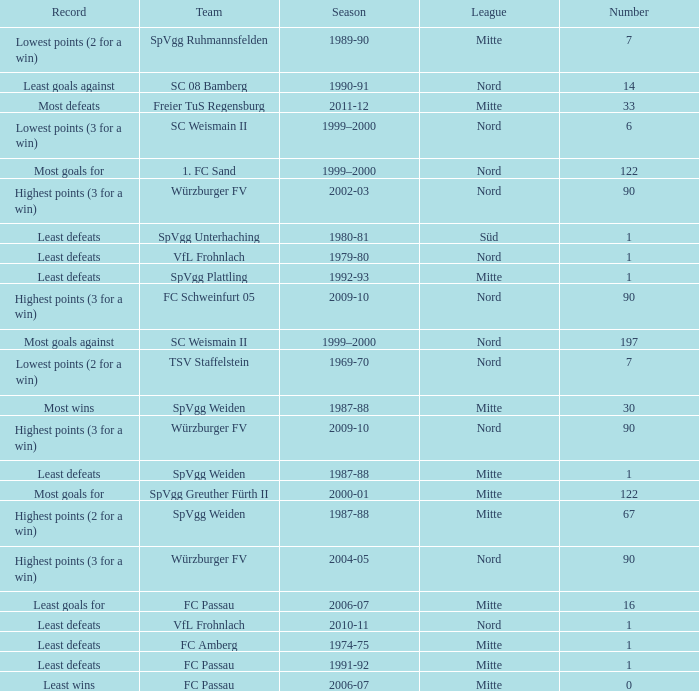What league has a number less than 122, and least wins as the record? Mitte. 